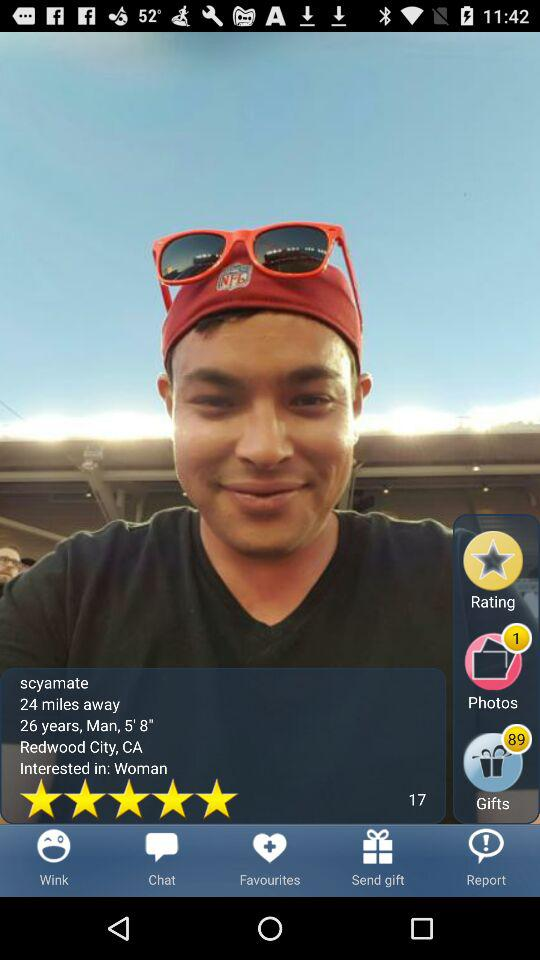What is the gender?
When the provided information is insufficient, respond with <no answer>. <no answer> 